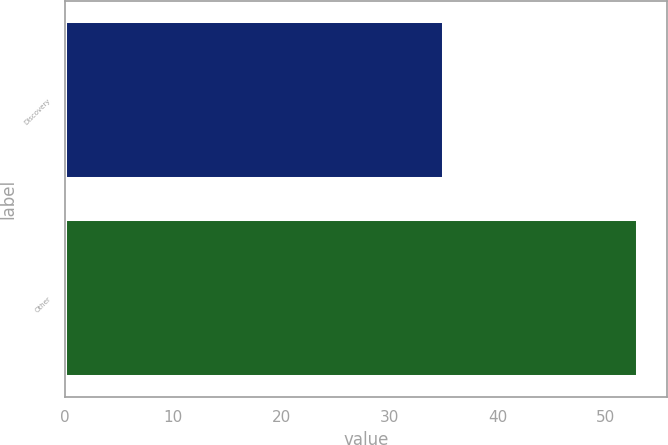Convert chart. <chart><loc_0><loc_0><loc_500><loc_500><bar_chart><fcel>Discovery<fcel>Other<nl><fcel>35<fcel>53<nl></chart> 